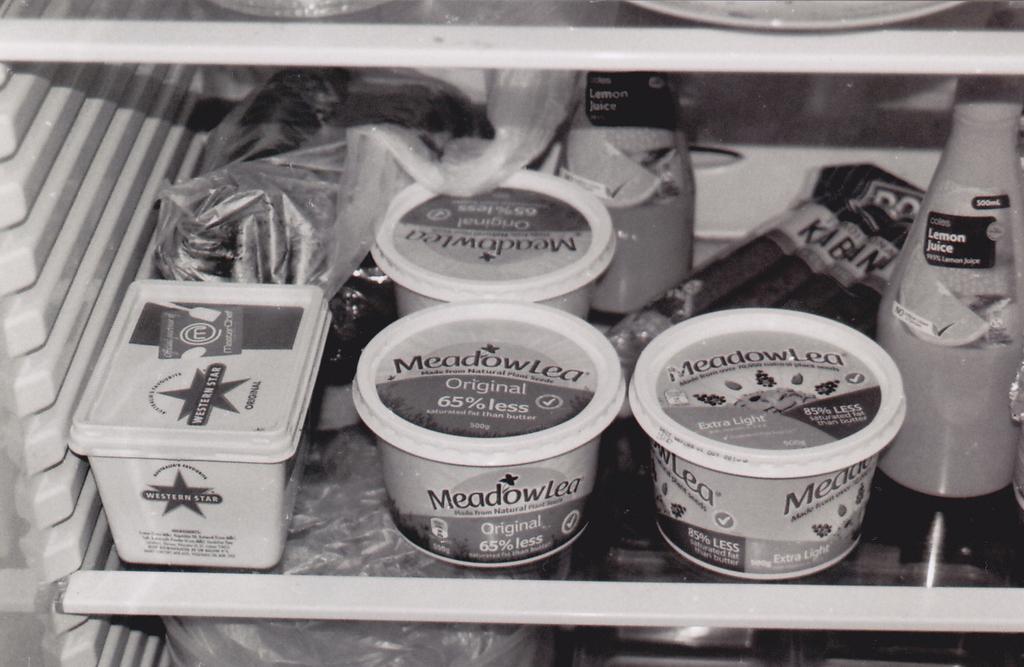Describe this image in one or two sentences. This image is of a refrigerator in which there are objects arranged in it. 